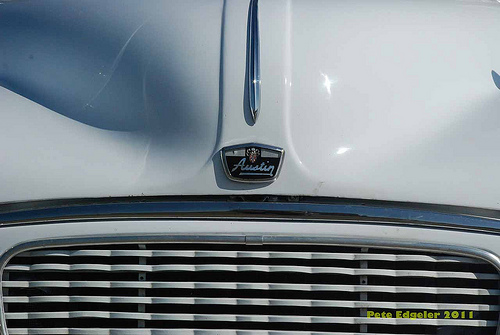<image>
Is there a logo to the left of the car? No. The logo is not to the left of the car. From this viewpoint, they have a different horizontal relationship. 